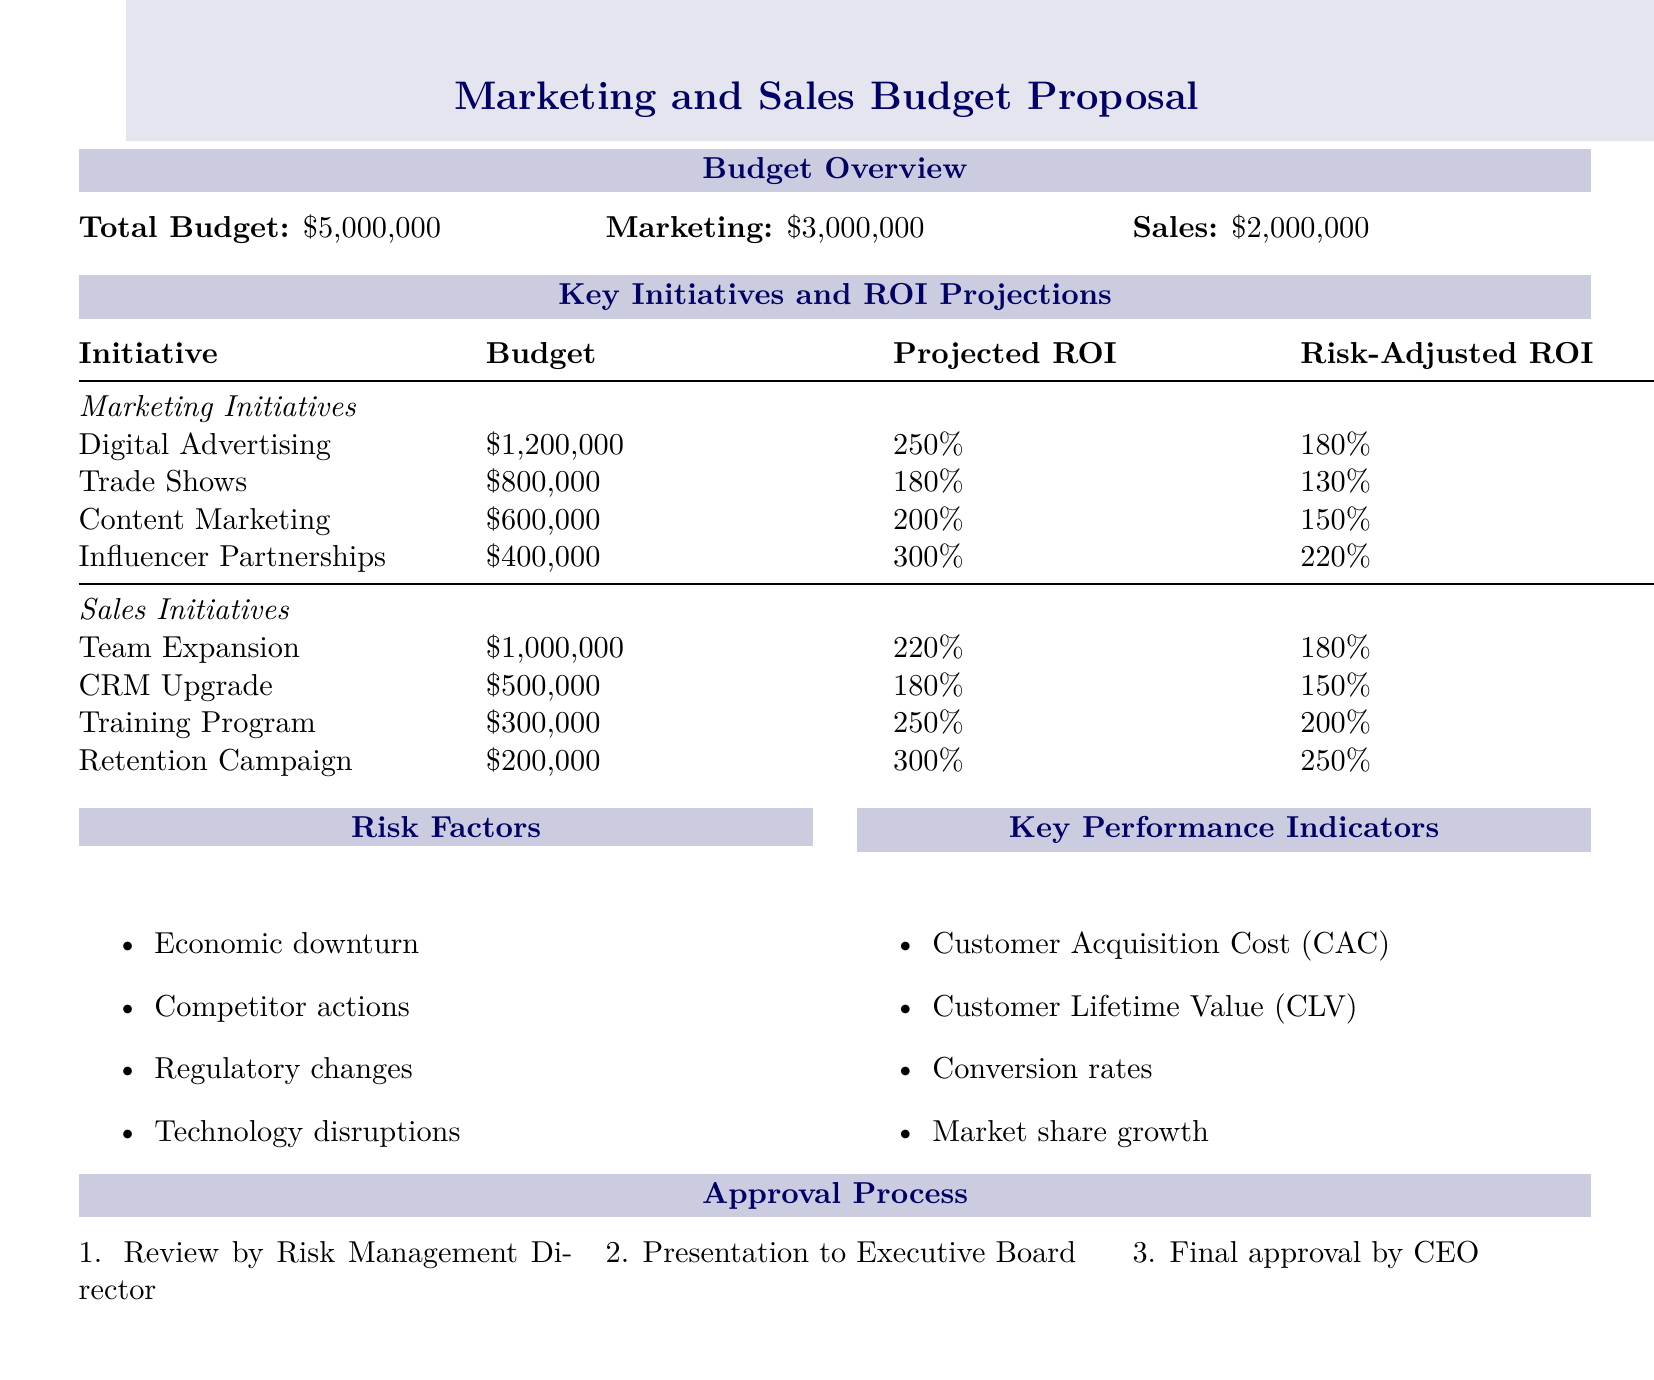What is the total budget? The total budget is explicitly stated in the document as $5,000,000.
Answer: $5,000,000 What is the budget allocated for Marketing? The document specifies that the marketing budget is part of the total budget.
Answer: $3,000,000 What is the projected ROI for Influencer Partnerships? The projected ROI is listed under the key initiatives for Marketing, specifically for Influencer Partnerships.
Answer: 300% What are the risk factors mentioned? The document lists four specific risk factors that impact the proposed budget.
Answer: Economic downturn, Competitor actions, Regulatory changes, Technology disruptions What is the approval process for the budget proposal? The document outlines a three-step approval process including a review by the Risk Management Director.
Answer: Review by Risk Management Director, Presentation to Executive Board, Final approval by CEO What is the risk-adjusted ROI for Team Expansion? The risk-adjusted ROI for Team Expansion is provided in the sales initiatives section of the document.
Answer: 180% Which initiative has the highest projected ROI? The document shows that Influencer Partnerships has the highest projected ROI among the initiatives listed.
Answer: 300% Which KPI measures Customer Acquisition Cost? The key performance indicator (KPI) related to measuring costs associated with acquiring customers is listed in the document.
Answer: Customer Acquisition Cost (CAC) What is the total budget for Sales initiatives? The total budget for Sales initiatives can be calculated from the individual sales initiative budgets provided in the document.
Answer: $2,000,000 